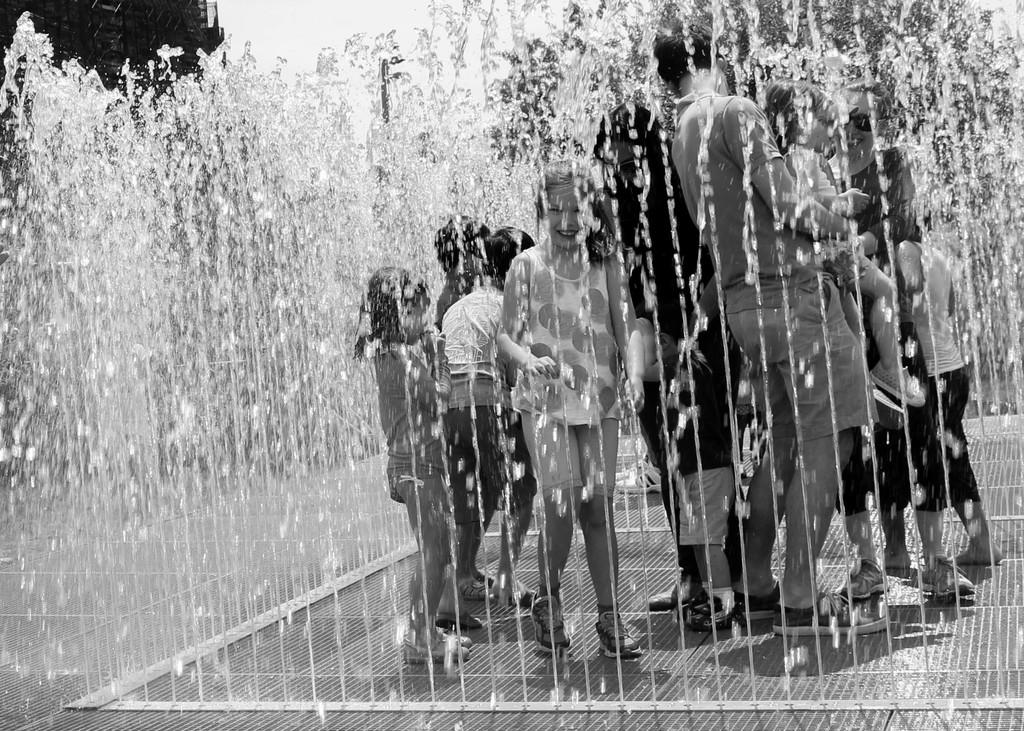What is the color scheme of the image? The image is black and white. What can be seen in the image besides the color scheme? There are people in the image. Where are the people located in the image? The people are on the floor. What else is visible in the image? There is water visible in the image. What type of note is being played by the loaf in the image? There is no loaf or note being played in the image; it features people on the floor and water. 